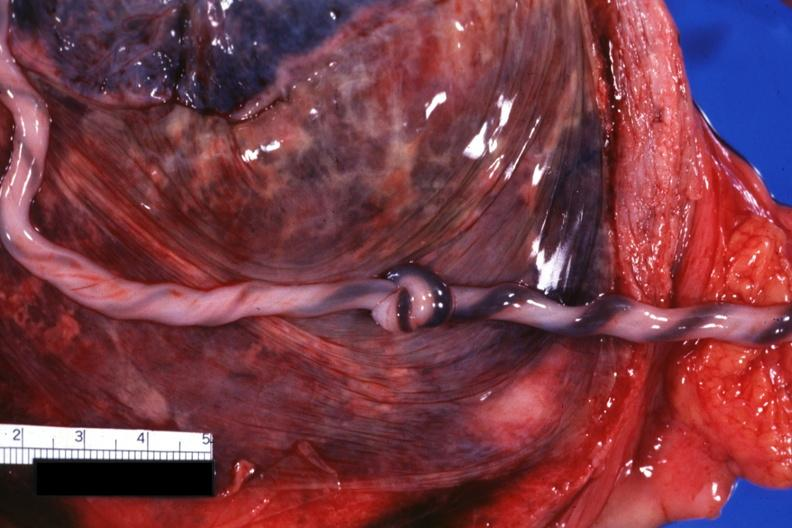s umbilical cord present?
Answer the question using a single word or phrase. Yes 